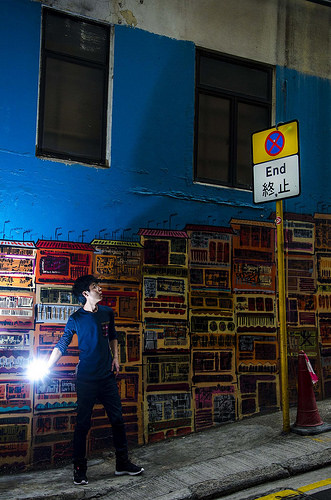<image>
Is the man under the street sign? Yes. The man is positioned underneath the street sign, with the street sign above it in the vertical space. 